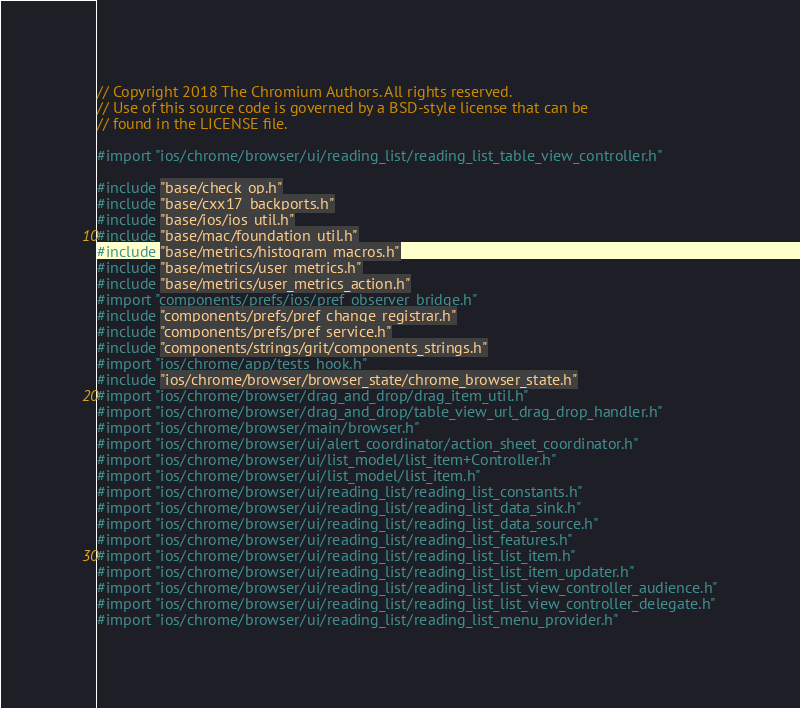Convert code to text. <code><loc_0><loc_0><loc_500><loc_500><_ObjectiveC_>// Copyright 2018 The Chromium Authors. All rights reserved.
// Use of this source code is governed by a BSD-style license that can be
// found in the LICENSE file.

#import "ios/chrome/browser/ui/reading_list/reading_list_table_view_controller.h"

#include "base/check_op.h"
#include "base/cxx17_backports.h"
#include "base/ios/ios_util.h"
#include "base/mac/foundation_util.h"
#include "base/metrics/histogram_macros.h"
#include "base/metrics/user_metrics.h"
#include "base/metrics/user_metrics_action.h"
#import "components/prefs/ios/pref_observer_bridge.h"
#include "components/prefs/pref_change_registrar.h"
#include "components/prefs/pref_service.h"
#include "components/strings/grit/components_strings.h"
#import "ios/chrome/app/tests_hook.h"
#include "ios/chrome/browser/browser_state/chrome_browser_state.h"
#import "ios/chrome/browser/drag_and_drop/drag_item_util.h"
#import "ios/chrome/browser/drag_and_drop/table_view_url_drag_drop_handler.h"
#import "ios/chrome/browser/main/browser.h"
#import "ios/chrome/browser/ui/alert_coordinator/action_sheet_coordinator.h"
#import "ios/chrome/browser/ui/list_model/list_item+Controller.h"
#import "ios/chrome/browser/ui/list_model/list_item.h"
#import "ios/chrome/browser/ui/reading_list/reading_list_constants.h"
#import "ios/chrome/browser/ui/reading_list/reading_list_data_sink.h"
#import "ios/chrome/browser/ui/reading_list/reading_list_data_source.h"
#import "ios/chrome/browser/ui/reading_list/reading_list_features.h"
#import "ios/chrome/browser/ui/reading_list/reading_list_list_item.h"
#import "ios/chrome/browser/ui/reading_list/reading_list_list_item_updater.h"
#import "ios/chrome/browser/ui/reading_list/reading_list_list_view_controller_audience.h"
#import "ios/chrome/browser/ui/reading_list/reading_list_list_view_controller_delegate.h"
#import "ios/chrome/browser/ui/reading_list/reading_list_menu_provider.h"</code> 